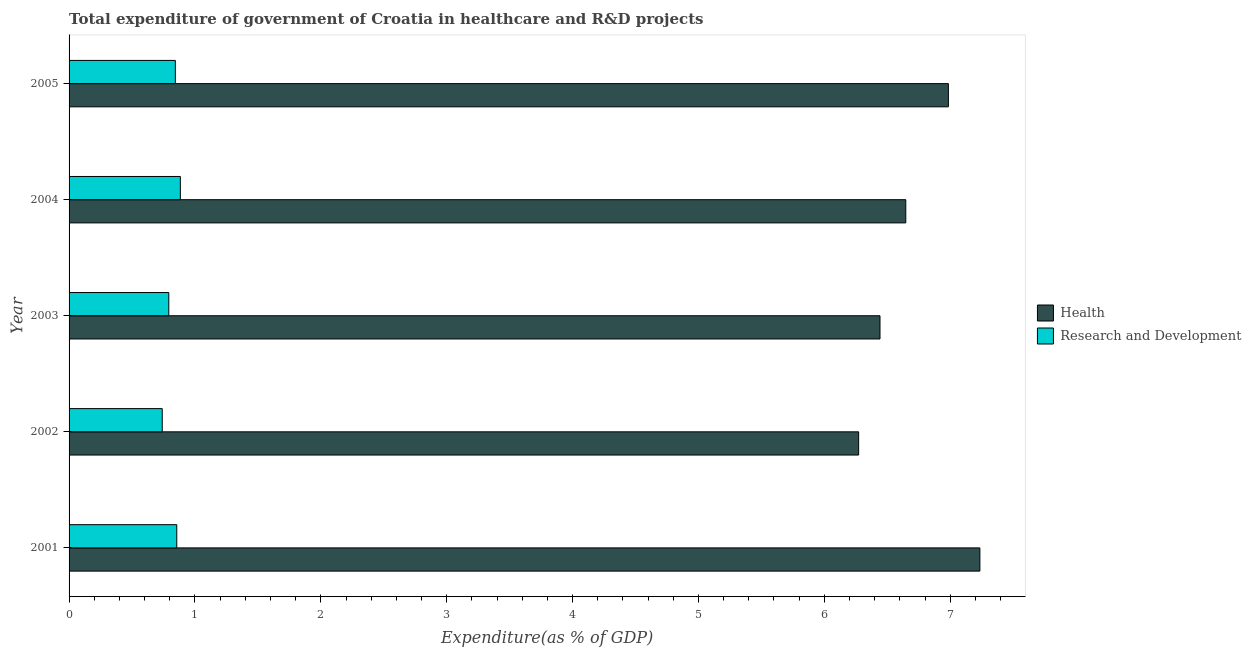How many different coloured bars are there?
Your answer should be compact. 2. How many groups of bars are there?
Provide a short and direct response. 5. Are the number of bars per tick equal to the number of legend labels?
Make the answer very short. Yes. Are the number of bars on each tick of the Y-axis equal?
Offer a terse response. Yes. How many bars are there on the 4th tick from the top?
Offer a very short reply. 2. How many bars are there on the 1st tick from the bottom?
Your answer should be compact. 2. What is the expenditure in healthcare in 2005?
Make the answer very short. 6.99. Across all years, what is the maximum expenditure in r&d?
Offer a terse response. 0.88. Across all years, what is the minimum expenditure in healthcare?
Keep it short and to the point. 6.27. In which year was the expenditure in r&d minimum?
Give a very brief answer. 2002. What is the total expenditure in r&d in the graph?
Offer a very short reply. 4.12. What is the difference between the expenditure in r&d in 2003 and that in 2005?
Your answer should be very brief. -0.05. What is the difference between the expenditure in healthcare in 2001 and the expenditure in r&d in 2005?
Your answer should be very brief. 6.39. What is the average expenditure in r&d per year?
Provide a succinct answer. 0.82. In the year 2001, what is the difference between the expenditure in r&d and expenditure in healthcare?
Your response must be concise. -6.38. In how many years, is the expenditure in r&d greater than 1.8 %?
Offer a terse response. 0. What is the ratio of the expenditure in healthcare in 2001 to that in 2003?
Give a very brief answer. 1.12. What is the difference between the highest and the second highest expenditure in r&d?
Offer a very short reply. 0.03. What is the difference between the highest and the lowest expenditure in r&d?
Offer a terse response. 0.14. What does the 1st bar from the top in 2002 represents?
Your answer should be very brief. Research and Development. What does the 1st bar from the bottom in 2001 represents?
Offer a very short reply. Health. How many bars are there?
Provide a short and direct response. 10. How many years are there in the graph?
Keep it short and to the point. 5. What is the difference between two consecutive major ticks on the X-axis?
Provide a short and direct response. 1. Are the values on the major ticks of X-axis written in scientific E-notation?
Provide a succinct answer. No. Does the graph contain grids?
Provide a short and direct response. No. Where does the legend appear in the graph?
Your answer should be very brief. Center right. What is the title of the graph?
Your answer should be compact. Total expenditure of government of Croatia in healthcare and R&D projects. Does "Fraud firms" appear as one of the legend labels in the graph?
Ensure brevity in your answer.  No. What is the label or title of the X-axis?
Make the answer very short. Expenditure(as % of GDP). What is the Expenditure(as % of GDP) of Health in 2001?
Offer a very short reply. 7.24. What is the Expenditure(as % of GDP) of Research and Development in 2001?
Your answer should be very brief. 0.86. What is the Expenditure(as % of GDP) in Health in 2002?
Your response must be concise. 6.27. What is the Expenditure(as % of GDP) in Research and Development in 2002?
Offer a very short reply. 0.74. What is the Expenditure(as % of GDP) in Health in 2003?
Keep it short and to the point. 6.44. What is the Expenditure(as % of GDP) in Research and Development in 2003?
Your answer should be compact. 0.79. What is the Expenditure(as % of GDP) of Health in 2004?
Your answer should be very brief. 6.65. What is the Expenditure(as % of GDP) of Research and Development in 2004?
Your response must be concise. 0.88. What is the Expenditure(as % of GDP) of Health in 2005?
Give a very brief answer. 6.99. What is the Expenditure(as % of GDP) in Research and Development in 2005?
Provide a succinct answer. 0.84. Across all years, what is the maximum Expenditure(as % of GDP) in Health?
Make the answer very short. 7.24. Across all years, what is the maximum Expenditure(as % of GDP) of Research and Development?
Provide a short and direct response. 0.88. Across all years, what is the minimum Expenditure(as % of GDP) of Health?
Give a very brief answer. 6.27. Across all years, what is the minimum Expenditure(as % of GDP) in Research and Development?
Provide a short and direct response. 0.74. What is the total Expenditure(as % of GDP) of Health in the graph?
Ensure brevity in your answer.  33.58. What is the total Expenditure(as % of GDP) in Research and Development in the graph?
Your answer should be compact. 4.12. What is the difference between the Expenditure(as % of GDP) in Health in 2001 and that in 2002?
Offer a very short reply. 0.96. What is the difference between the Expenditure(as % of GDP) in Research and Development in 2001 and that in 2002?
Your response must be concise. 0.12. What is the difference between the Expenditure(as % of GDP) of Health in 2001 and that in 2003?
Your answer should be compact. 0.79. What is the difference between the Expenditure(as % of GDP) of Research and Development in 2001 and that in 2003?
Provide a succinct answer. 0.06. What is the difference between the Expenditure(as % of GDP) in Health in 2001 and that in 2004?
Keep it short and to the point. 0.59. What is the difference between the Expenditure(as % of GDP) in Research and Development in 2001 and that in 2004?
Your answer should be compact. -0.03. What is the difference between the Expenditure(as % of GDP) in Health in 2001 and that in 2005?
Offer a very short reply. 0.25. What is the difference between the Expenditure(as % of GDP) of Research and Development in 2001 and that in 2005?
Provide a short and direct response. 0.01. What is the difference between the Expenditure(as % of GDP) in Health in 2002 and that in 2003?
Provide a short and direct response. -0.17. What is the difference between the Expenditure(as % of GDP) of Research and Development in 2002 and that in 2003?
Ensure brevity in your answer.  -0.05. What is the difference between the Expenditure(as % of GDP) in Health in 2002 and that in 2004?
Ensure brevity in your answer.  -0.37. What is the difference between the Expenditure(as % of GDP) in Research and Development in 2002 and that in 2004?
Give a very brief answer. -0.14. What is the difference between the Expenditure(as % of GDP) of Health in 2002 and that in 2005?
Keep it short and to the point. -0.71. What is the difference between the Expenditure(as % of GDP) of Research and Development in 2002 and that in 2005?
Give a very brief answer. -0.1. What is the difference between the Expenditure(as % of GDP) of Health in 2003 and that in 2004?
Your response must be concise. -0.2. What is the difference between the Expenditure(as % of GDP) in Research and Development in 2003 and that in 2004?
Your answer should be very brief. -0.09. What is the difference between the Expenditure(as % of GDP) in Health in 2003 and that in 2005?
Ensure brevity in your answer.  -0.54. What is the difference between the Expenditure(as % of GDP) of Research and Development in 2003 and that in 2005?
Give a very brief answer. -0.05. What is the difference between the Expenditure(as % of GDP) in Health in 2004 and that in 2005?
Make the answer very short. -0.34. What is the difference between the Expenditure(as % of GDP) in Research and Development in 2004 and that in 2005?
Offer a very short reply. 0.04. What is the difference between the Expenditure(as % of GDP) in Health in 2001 and the Expenditure(as % of GDP) in Research and Development in 2002?
Keep it short and to the point. 6.5. What is the difference between the Expenditure(as % of GDP) of Health in 2001 and the Expenditure(as % of GDP) of Research and Development in 2003?
Make the answer very short. 6.44. What is the difference between the Expenditure(as % of GDP) in Health in 2001 and the Expenditure(as % of GDP) in Research and Development in 2004?
Your response must be concise. 6.35. What is the difference between the Expenditure(as % of GDP) in Health in 2001 and the Expenditure(as % of GDP) in Research and Development in 2005?
Make the answer very short. 6.39. What is the difference between the Expenditure(as % of GDP) in Health in 2002 and the Expenditure(as % of GDP) in Research and Development in 2003?
Keep it short and to the point. 5.48. What is the difference between the Expenditure(as % of GDP) in Health in 2002 and the Expenditure(as % of GDP) in Research and Development in 2004?
Your response must be concise. 5.39. What is the difference between the Expenditure(as % of GDP) of Health in 2002 and the Expenditure(as % of GDP) of Research and Development in 2005?
Provide a short and direct response. 5.43. What is the difference between the Expenditure(as % of GDP) of Health in 2003 and the Expenditure(as % of GDP) of Research and Development in 2004?
Provide a short and direct response. 5.56. What is the difference between the Expenditure(as % of GDP) in Health in 2003 and the Expenditure(as % of GDP) in Research and Development in 2005?
Offer a very short reply. 5.6. What is the difference between the Expenditure(as % of GDP) of Health in 2004 and the Expenditure(as % of GDP) of Research and Development in 2005?
Offer a very short reply. 5.8. What is the average Expenditure(as % of GDP) of Health per year?
Your answer should be very brief. 6.72. What is the average Expenditure(as % of GDP) in Research and Development per year?
Offer a terse response. 0.82. In the year 2001, what is the difference between the Expenditure(as % of GDP) of Health and Expenditure(as % of GDP) of Research and Development?
Your answer should be very brief. 6.38. In the year 2002, what is the difference between the Expenditure(as % of GDP) in Health and Expenditure(as % of GDP) in Research and Development?
Give a very brief answer. 5.53. In the year 2003, what is the difference between the Expenditure(as % of GDP) in Health and Expenditure(as % of GDP) in Research and Development?
Your answer should be compact. 5.65. In the year 2004, what is the difference between the Expenditure(as % of GDP) of Health and Expenditure(as % of GDP) of Research and Development?
Your answer should be compact. 5.76. In the year 2005, what is the difference between the Expenditure(as % of GDP) in Health and Expenditure(as % of GDP) in Research and Development?
Keep it short and to the point. 6.14. What is the ratio of the Expenditure(as % of GDP) of Health in 2001 to that in 2002?
Your response must be concise. 1.15. What is the ratio of the Expenditure(as % of GDP) of Research and Development in 2001 to that in 2002?
Keep it short and to the point. 1.16. What is the ratio of the Expenditure(as % of GDP) in Health in 2001 to that in 2003?
Keep it short and to the point. 1.12. What is the ratio of the Expenditure(as % of GDP) in Research and Development in 2001 to that in 2003?
Your response must be concise. 1.08. What is the ratio of the Expenditure(as % of GDP) in Health in 2001 to that in 2004?
Make the answer very short. 1.09. What is the ratio of the Expenditure(as % of GDP) in Health in 2001 to that in 2005?
Make the answer very short. 1.04. What is the ratio of the Expenditure(as % of GDP) of Research and Development in 2001 to that in 2005?
Your answer should be compact. 1.01. What is the ratio of the Expenditure(as % of GDP) in Health in 2002 to that in 2003?
Ensure brevity in your answer.  0.97. What is the ratio of the Expenditure(as % of GDP) of Research and Development in 2002 to that in 2003?
Your response must be concise. 0.93. What is the ratio of the Expenditure(as % of GDP) in Health in 2002 to that in 2004?
Your answer should be compact. 0.94. What is the ratio of the Expenditure(as % of GDP) in Research and Development in 2002 to that in 2004?
Ensure brevity in your answer.  0.84. What is the ratio of the Expenditure(as % of GDP) in Health in 2002 to that in 2005?
Ensure brevity in your answer.  0.9. What is the ratio of the Expenditure(as % of GDP) of Research and Development in 2002 to that in 2005?
Your answer should be compact. 0.88. What is the ratio of the Expenditure(as % of GDP) of Health in 2003 to that in 2004?
Your answer should be compact. 0.97. What is the ratio of the Expenditure(as % of GDP) in Research and Development in 2003 to that in 2004?
Your response must be concise. 0.9. What is the ratio of the Expenditure(as % of GDP) of Health in 2003 to that in 2005?
Make the answer very short. 0.92. What is the ratio of the Expenditure(as % of GDP) in Research and Development in 2003 to that in 2005?
Offer a very short reply. 0.94. What is the ratio of the Expenditure(as % of GDP) of Health in 2004 to that in 2005?
Make the answer very short. 0.95. What is the ratio of the Expenditure(as % of GDP) in Research and Development in 2004 to that in 2005?
Ensure brevity in your answer.  1.05. What is the difference between the highest and the second highest Expenditure(as % of GDP) of Health?
Provide a succinct answer. 0.25. What is the difference between the highest and the second highest Expenditure(as % of GDP) of Research and Development?
Provide a short and direct response. 0.03. What is the difference between the highest and the lowest Expenditure(as % of GDP) in Health?
Offer a very short reply. 0.96. What is the difference between the highest and the lowest Expenditure(as % of GDP) of Research and Development?
Your answer should be very brief. 0.14. 